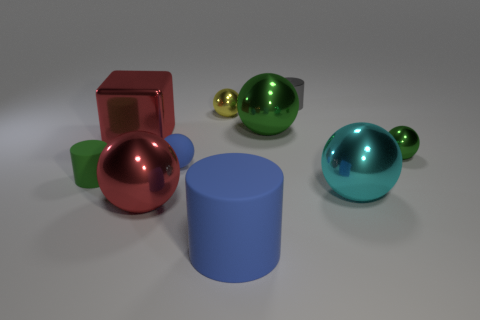Subtract all red spheres. How many spheres are left? 5 Subtract all large cyan metal balls. How many balls are left? 5 Subtract 1 spheres. How many spheres are left? 5 Subtract all gray balls. Subtract all cyan cylinders. How many balls are left? 6 Subtract all balls. How many objects are left? 4 Add 7 small blue matte balls. How many small blue matte balls exist? 8 Subtract 0 cyan cylinders. How many objects are left? 10 Subtract all big green spheres. Subtract all green metallic balls. How many objects are left? 7 Add 1 red metallic cubes. How many red metallic cubes are left? 2 